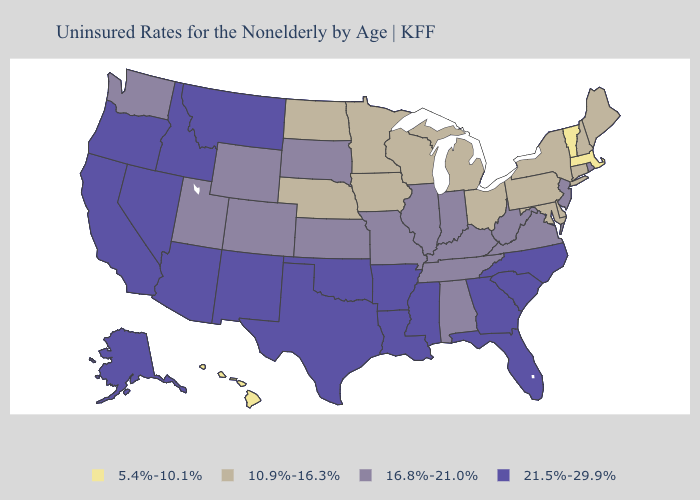What is the value of Tennessee?
Give a very brief answer. 16.8%-21.0%. Name the states that have a value in the range 21.5%-29.9%?
Quick response, please. Alaska, Arizona, Arkansas, California, Florida, Georgia, Idaho, Louisiana, Mississippi, Montana, Nevada, New Mexico, North Carolina, Oklahoma, Oregon, South Carolina, Texas. What is the value of North Dakota?
Keep it brief. 10.9%-16.3%. Does Nevada have the highest value in the USA?
Answer briefly. Yes. What is the value of South Carolina?
Keep it brief. 21.5%-29.9%. Does Hawaii have the lowest value in the USA?
Keep it brief. Yes. Is the legend a continuous bar?
Short answer required. No. What is the lowest value in states that border New York?
Answer briefly. 5.4%-10.1%. What is the lowest value in states that border Indiana?
Concise answer only. 10.9%-16.3%. Does the map have missing data?
Concise answer only. No. What is the value of North Carolina?
Keep it brief. 21.5%-29.9%. What is the lowest value in the USA?
Keep it brief. 5.4%-10.1%. Does Rhode Island have the highest value in the Northeast?
Be succinct. Yes. How many symbols are there in the legend?
Write a very short answer. 4. Among the states that border Utah , which have the highest value?
Write a very short answer. Arizona, Idaho, Nevada, New Mexico. 